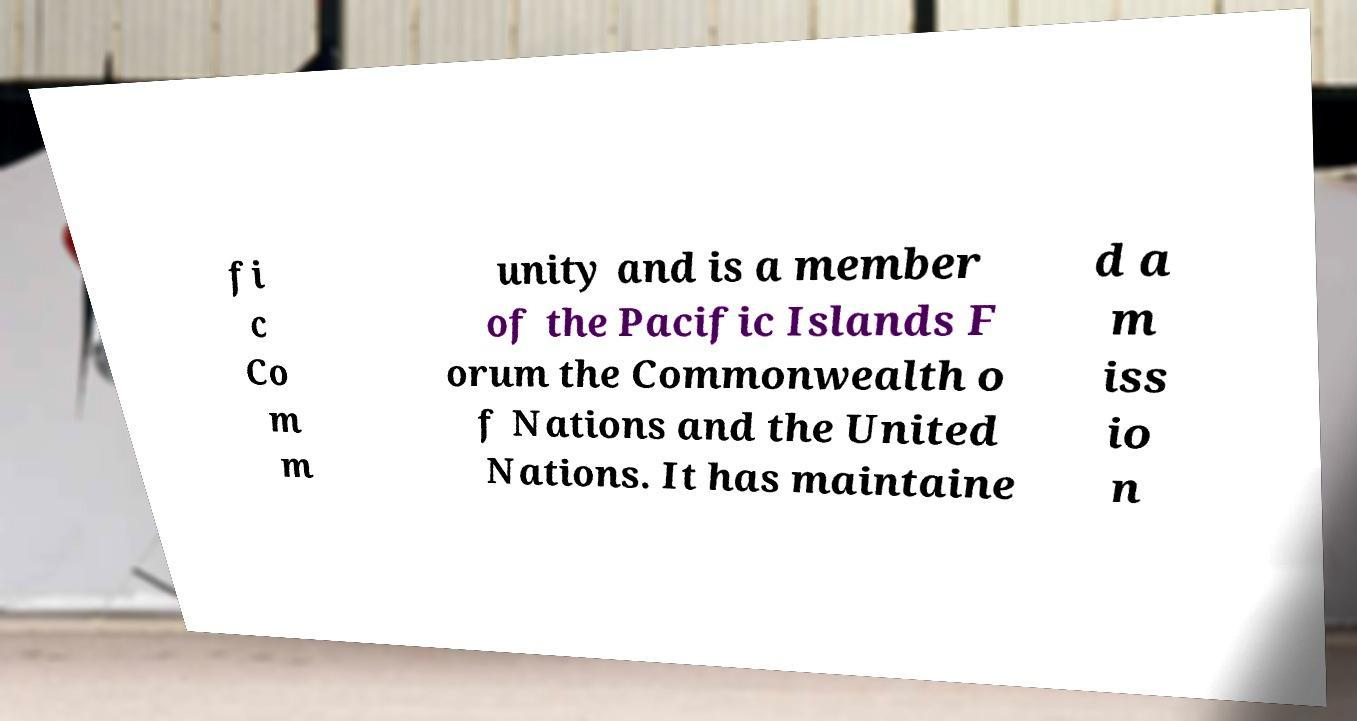Please identify and transcribe the text found in this image. fi c Co m m unity and is a member of the Pacific Islands F orum the Commonwealth o f Nations and the United Nations. It has maintaine d a m iss io n 